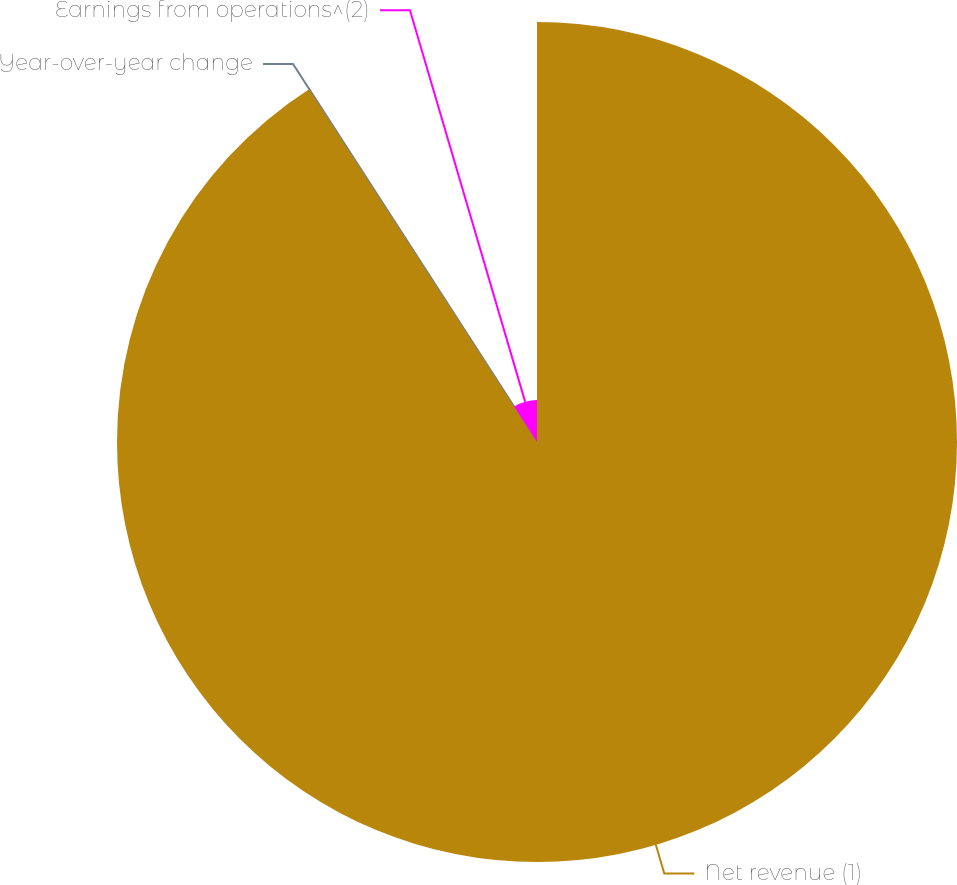<chart> <loc_0><loc_0><loc_500><loc_500><pie_chart><fcel>Net revenue (1)<fcel>Year-over-year change<fcel>Earnings from operations^(2)<nl><fcel>90.87%<fcel>0.02%<fcel>9.11%<nl></chart> 